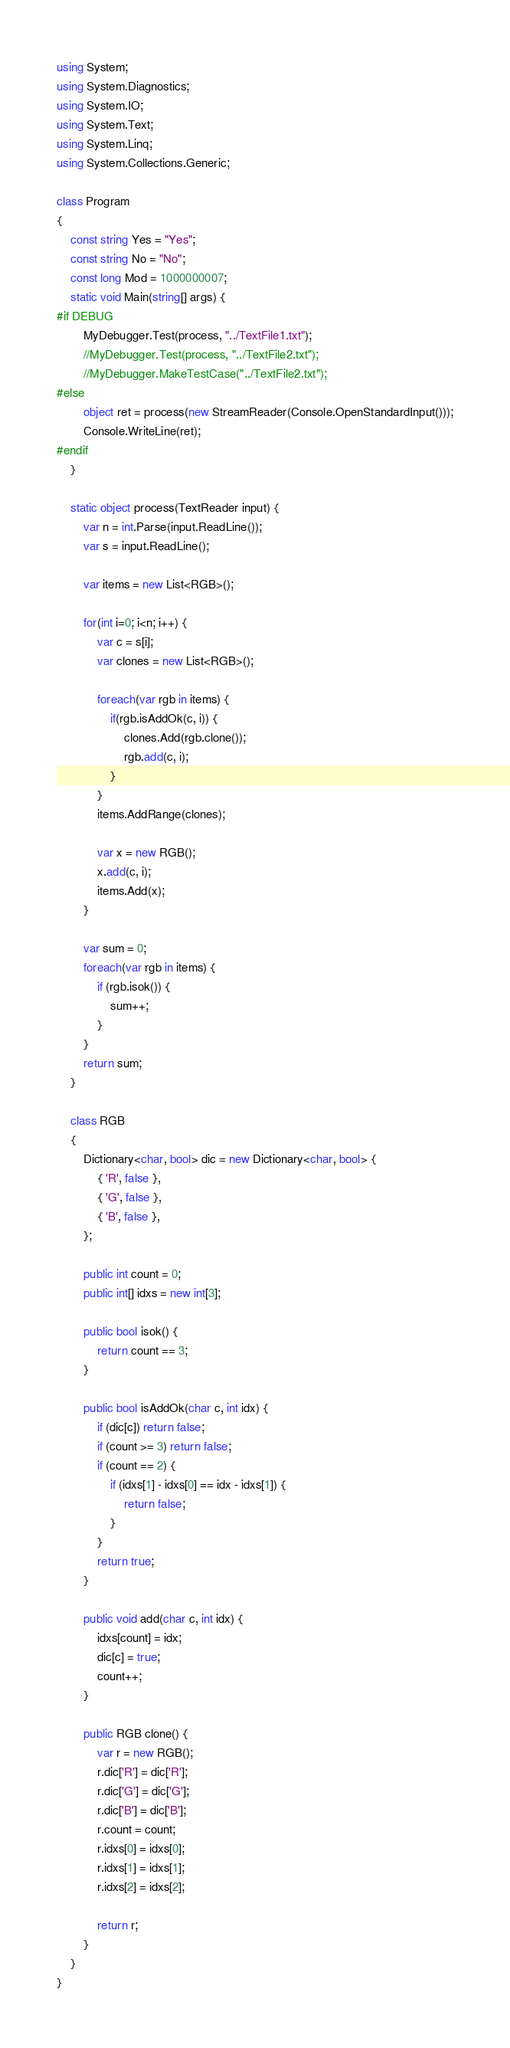Convert code to text. <code><loc_0><loc_0><loc_500><loc_500><_C#_>using System;
using System.Diagnostics;
using System.IO;
using System.Text;
using System.Linq;
using System.Collections.Generic;

class Program
{
    const string Yes = "Yes";
    const string No = "No";
    const long Mod = 1000000007;
    static void Main(string[] args) {
#if DEBUG
        MyDebugger.Test(process, "../TextFile1.txt");
        //MyDebugger.Test(process, "../TextFile2.txt");
        //MyDebugger.MakeTestCase("../TextFile2.txt");
#else
        object ret = process(new StreamReader(Console.OpenStandardInput()));
        Console.WriteLine(ret);
#endif
    }

    static object process(TextReader input) {
        var n = int.Parse(input.ReadLine());
        var s = input.ReadLine();

        var items = new List<RGB>();

        for(int i=0; i<n; i++) {
            var c = s[i];
            var clones = new List<RGB>(); 

            foreach(var rgb in items) {
                if(rgb.isAddOk(c, i)) {
                    clones.Add(rgb.clone());
                    rgb.add(c, i);
                }
            }
            items.AddRange(clones);

            var x = new RGB();
            x.add(c, i);
            items.Add(x);
        }

        var sum = 0;
        foreach(var rgb in items) {
            if (rgb.isok()) {
                sum++;
            }
        }
        return sum;
    }

    class RGB
    {
        Dictionary<char, bool> dic = new Dictionary<char, bool> {
            { 'R', false },
            { 'G', false },
            { 'B', false },
        };

        public int count = 0;
        public int[] idxs = new int[3];

        public bool isok() {
            return count == 3;
        }

        public bool isAddOk(char c, int idx) {
            if (dic[c]) return false;
            if (count >= 3) return false;
            if (count == 2) {
                if (idxs[1] - idxs[0] == idx - idxs[1]) {
                    return false;
                }
            }
            return true;
        }

        public void add(char c, int idx) {
            idxs[count] = idx;
            dic[c] = true;
            count++;
        }

        public RGB clone() {
            var r = new RGB();
            r.dic['R'] = dic['R'];
            r.dic['G'] = dic['G'];
            r.dic['B'] = dic['B'];
            r.count = count;
            r.idxs[0] = idxs[0];
            r.idxs[1] = idxs[1];
            r.idxs[2] = idxs[2];

            return r;
        }
    }
}
</code> 